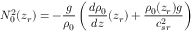Convert formula to latex. <formula><loc_0><loc_0><loc_500><loc_500>N _ { 0 } ^ { 2 } ( z _ { r } ) = - \frac { g } { \rho _ { 0 } } \left ( \frac { d \rho _ { 0 } } { d z } ( z _ { r } ) + \frac { \rho _ { 0 } ( z _ { r } ) g } { c _ { s r } ^ { 2 } } \right )</formula> 